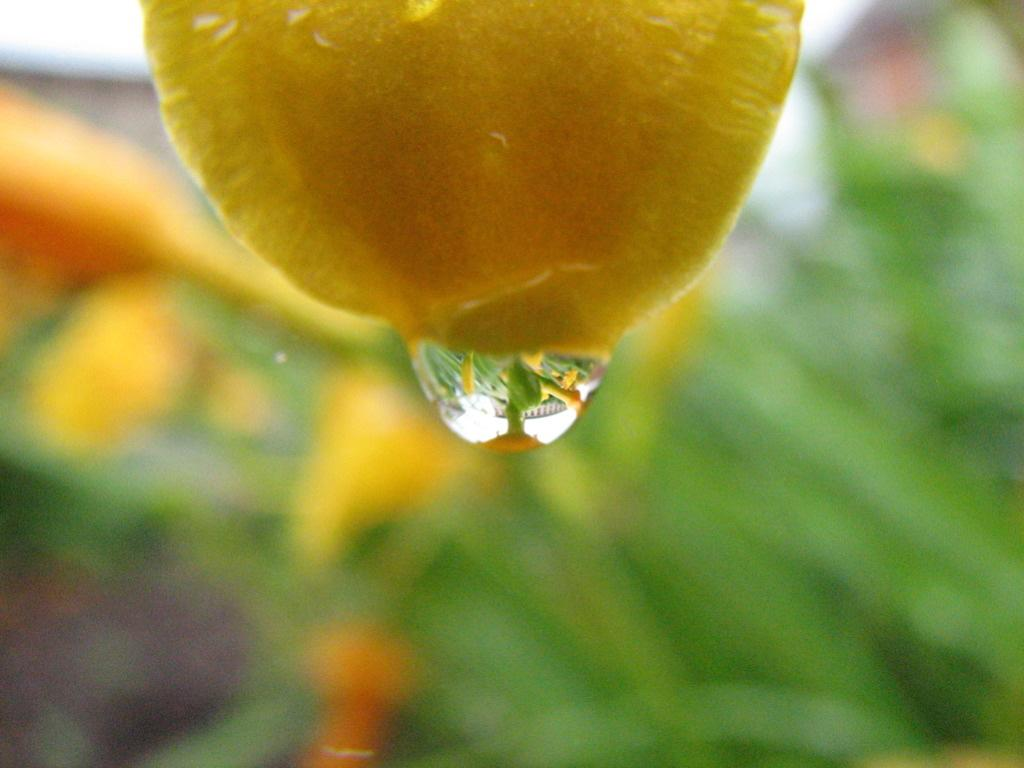What is the main subject in the foreground of the image? There is a fruit in the foreground of the image. What is a noticeable feature of the fruit? There are water droplets coming out of the fruit. How would you describe the background of the image? The background of the image is blurred. Is there a box in the image that is making a quiet noise? There is no box or any noise mentioned in the image; it only features a fruit with water droplets and a blurred background. 